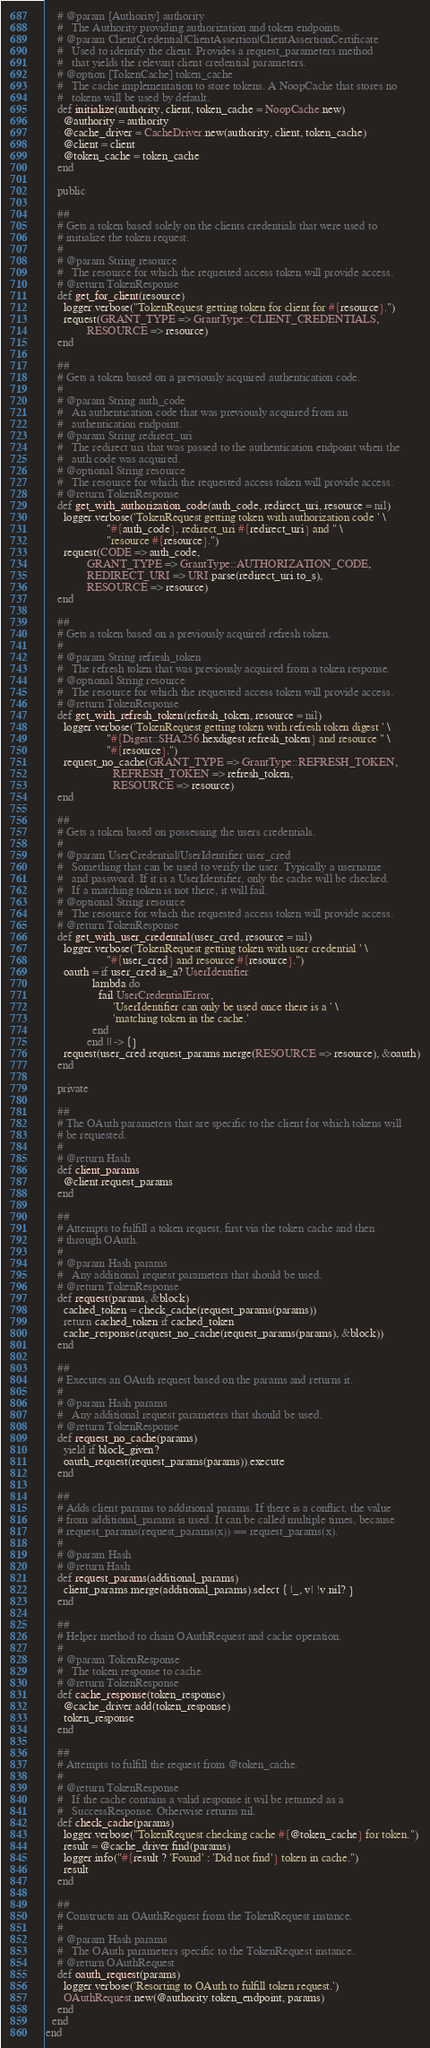<code> <loc_0><loc_0><loc_500><loc_500><_Ruby_>    # @param [Authority] authority
    #   The Authority providing authorization and token endpoints.
    # @param ClientCredential|ClientAssertion|ClientAssertionCertificate
    #   Used to identify the client. Provides a request_parameters method
    #   that yields the relevant client credential parameters.
    # @option [TokenCache] token_cache
    #   The cache implementation to store tokens. A NoopCache that stores no
    #   tokens will be used by default.
    def initialize(authority, client, token_cache = NoopCache.new)
      @authority = authority
      @cache_driver = CacheDriver.new(authority, client, token_cache)
      @client = client
      @token_cache = token_cache
    end

    public

    ##
    # Gets a token based solely on the clients credentials that were used to
    # initialize the token request.
    #
    # @param String resource
    #   The resource for which the requested access token will provide access.
    # @return TokenResponse
    def get_for_client(resource)
      logger.verbose("TokenRequest getting token for client for #{resource}.")
      request(GRANT_TYPE => GrantType::CLIENT_CREDENTIALS,
              RESOURCE => resource)
    end

    ##
    # Gets a token based on a previously acquired authentication code.
    #
    # @param String auth_code
    #   An authentication code that was previously acquired from an
    #   authentication endpoint.
    # @param String redirect_uri
    #   The redirect uri that was passed to the authentication endpoint when the
    #   auth code was acquired.
    # @optional String resource
    #   The resource for which the requested access token will provide access.
    # @return TokenResponse
    def get_with_authorization_code(auth_code, redirect_uri, resource = nil)
      logger.verbose('TokenRequest getting token with authorization code ' \
                     "#{auth_code}, redirect_uri #{redirect_uri} and " \
                     "resource #{resource}.")
      request(CODE => auth_code,
              GRANT_TYPE => GrantType::AUTHORIZATION_CODE,
              REDIRECT_URI => URI.parse(redirect_uri.to_s),
              RESOURCE => resource)
    end

    ##
    # Gets a token based on a previously acquired refresh token.
    #
    # @param String refresh_token
    #   The refresh token that was previously acquired from a token response.
    # @optional String resource
    #   The resource for which the requested access token will provide access.
    # @return TokenResponse
    def get_with_refresh_token(refresh_token, resource = nil)
      logger.verbose('TokenRequest getting token with refresh token digest ' \
                     "#{Digest::SHA256.hexdigest refresh_token} and resource " \
                     "#{resource}.")
      request_no_cache(GRANT_TYPE => GrantType::REFRESH_TOKEN,
                       REFRESH_TOKEN => refresh_token,
                       RESOURCE => resource)
    end

    ##
    # Gets a token based on possessing the users credentials.
    #
    # @param UserCredential|UserIdentifier user_cred
    #   Something that can be used to verify the user. Typically a username
    #   and password. If it is a UserIdentifier, only the cache will be checked.
    #   If a matching token is not there, it will fail.
    # @optional String resource
    #   The resource for which the requested access token will provide access.
    # @return TokenResponse
    def get_with_user_credential(user_cred, resource = nil)
      logger.verbose('TokenRequest getting token with user credential ' \
                     "#{user_cred} and resource #{resource}.")
      oauth = if user_cred.is_a? UserIdentifier
                lambda do
                  fail UserCredentialError,
                       'UserIdentifier can only be used once there is a ' \
                       'matching token in the cache.'
                end
              end || -> {}
      request(user_cred.request_params.merge(RESOURCE => resource), &oauth)
    end

    private

    ##
    # The OAuth parameters that are specific to the client for which tokens will
    # be requested.
    #
    # @return Hash
    def client_params
      @client.request_params
    end

    ##
    # Attempts to fulfill a token request, first via the token cache and then
    # through OAuth.
    #
    # @param Hash params
    #   Any additional request parameters that should be used.
    # @return TokenResponse
    def request(params, &block)
      cached_token = check_cache(request_params(params))
      return cached_token if cached_token
      cache_response(request_no_cache(request_params(params), &block))
    end

    ##
    # Executes an OAuth request based on the params and returns it.
    #
    # @param Hash params
    #   Any additional request parameters that should be used.
    # @return TokenResponse
    def request_no_cache(params)
      yield if block_given?
      oauth_request(request_params(params)).execute
    end

    ##
    # Adds client params to additional params. If there is a conflict, the value
    # from additional_params is used. It can be called multiple times, because
    # request_params(request_params(x)) == request_params(x).
    #
    # @param Hash
    # @return Hash
    def request_params(additional_params)
      client_params.merge(additional_params).select { |_, v| !v.nil? }
    end

    ##
    # Helper method to chain OAuthRequest and cache operation.
    #
    # @param TokenResponse
    #   The token response to cache.
    # @return TokenResponse
    def cache_response(token_response)
      @cache_driver.add(token_response)
      token_response
    end

    ##
    # Attempts to fulfill the request from @token_cache.
    #
    # @return TokenResponse
    #   If the cache contains a valid response it wil be returned as a
    #   SuccessResponse. Otherwise returns nil.
    def check_cache(params)
      logger.verbose("TokenRequest checking cache #{@token_cache} for token.")
      result = @cache_driver.find(params)
      logger.info("#{result ? 'Found' : 'Did not find'} token in cache.")
      result
    end

    ##
    # Constructs an OAuthRequest from the TokenRequest instance.
    #
    # @param Hash params
    #   The OAuth parameters specific to the TokenRequest instance.
    # @return OAuthRequest
    def oauth_request(params)
      logger.verbose('Resorting to OAuth to fulfill token request.')
      OAuthRequest.new(@authority.token_endpoint, params)
    end
  end
end
</code> 